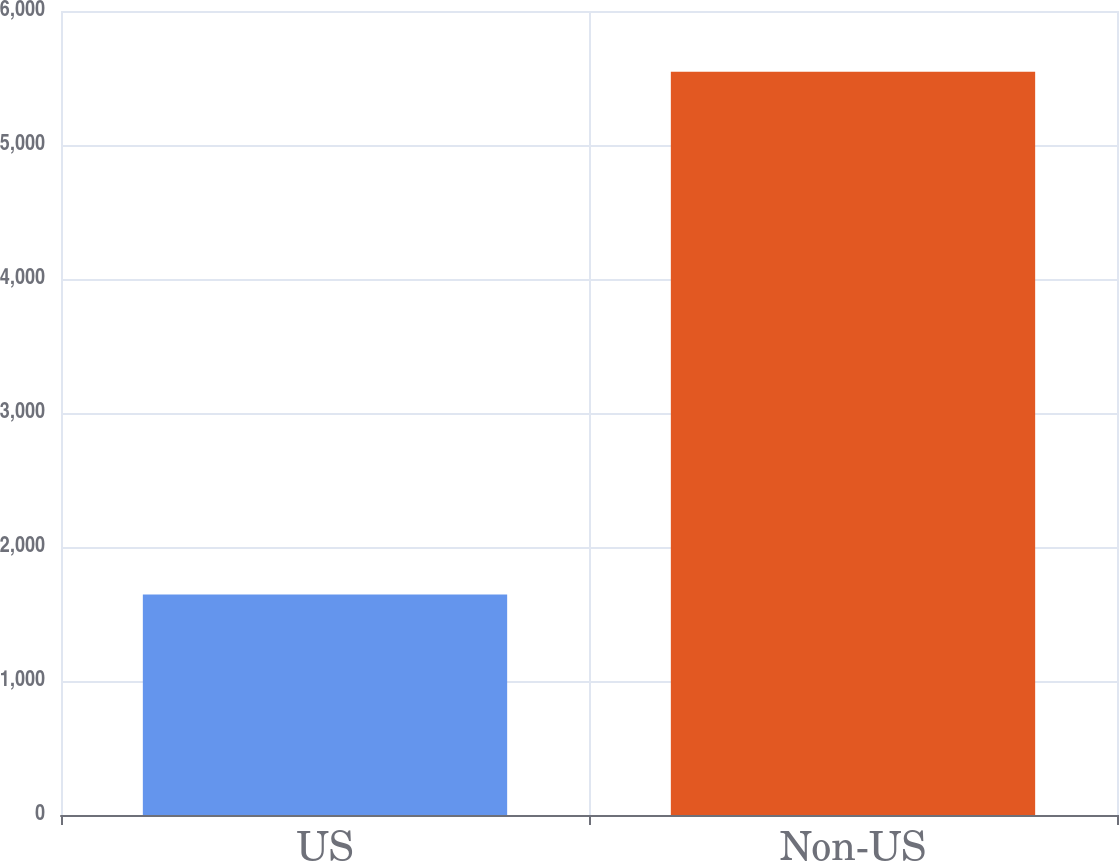<chart> <loc_0><loc_0><loc_500><loc_500><bar_chart><fcel>US<fcel>Non-US<nl><fcel>1645<fcel>5546<nl></chart> 